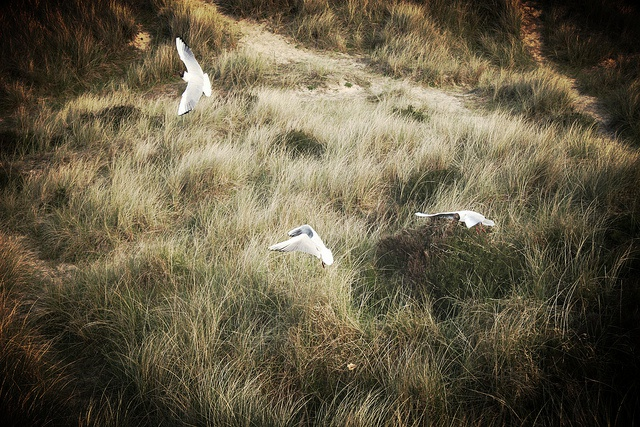Describe the objects in this image and their specific colors. I can see bird in black, white, darkgray, and gray tones, bird in black, white, darkgray, and lightgray tones, and bird in black, white, gray, and darkgray tones in this image. 